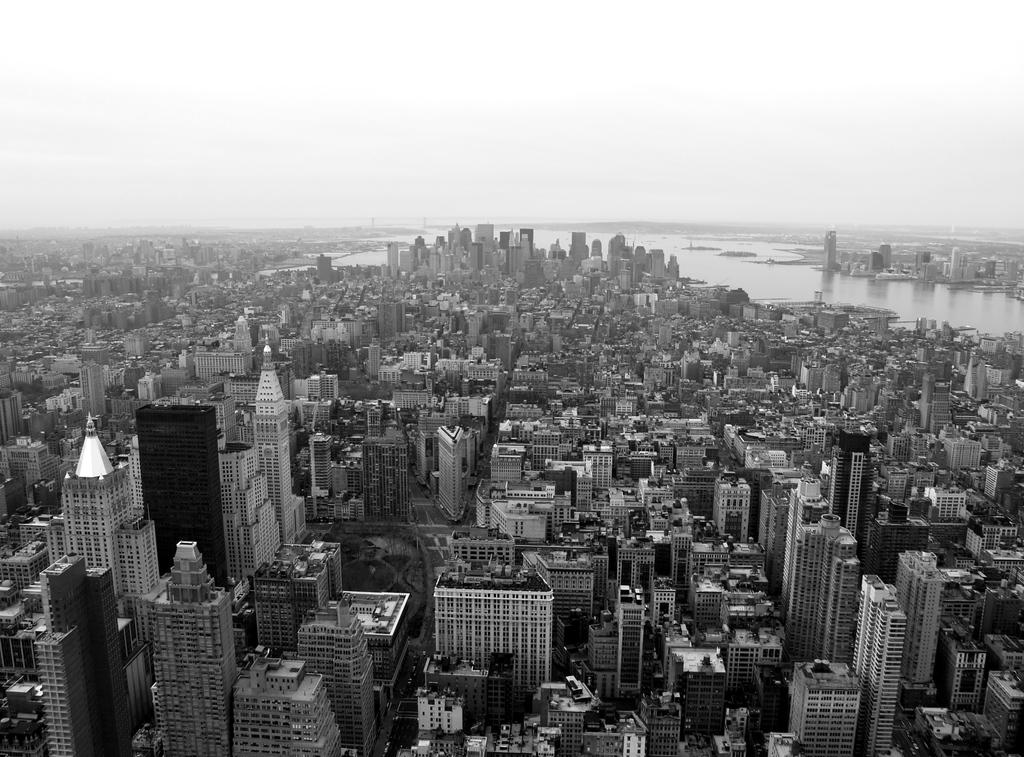What is the color scheme of the image? The image is black and white. What type of structures can be seen in the image? There are buildings in the image. What natural element is visible in the image? There is water visible in the image. What can be seen in the background of the image? The sky is visible in the background of the image. How many bells are hanging from the buildings in the image? There are no bells visible in the image; it only features buildings, water, and the sky. Can you tell me which leg is visible in the image? There are no legs present in the image; it is a black and white image of buildings, water, and the sky. 